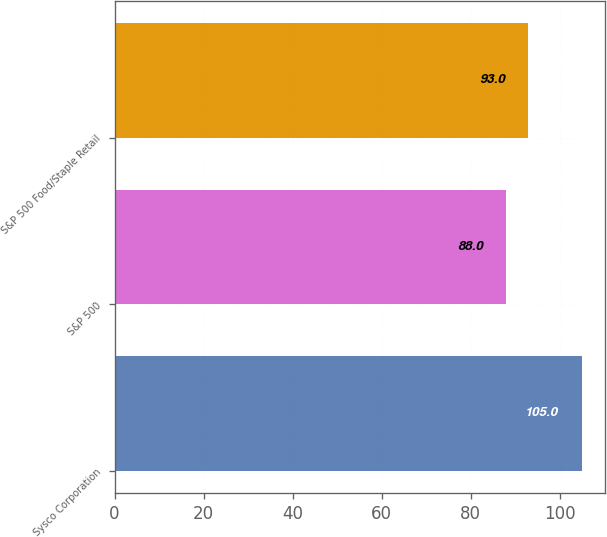Convert chart. <chart><loc_0><loc_0><loc_500><loc_500><bar_chart><fcel>Sysco Corporation<fcel>S&P 500<fcel>S&P 500 Food/Staple Retail<nl><fcel>105<fcel>88<fcel>93<nl></chart> 